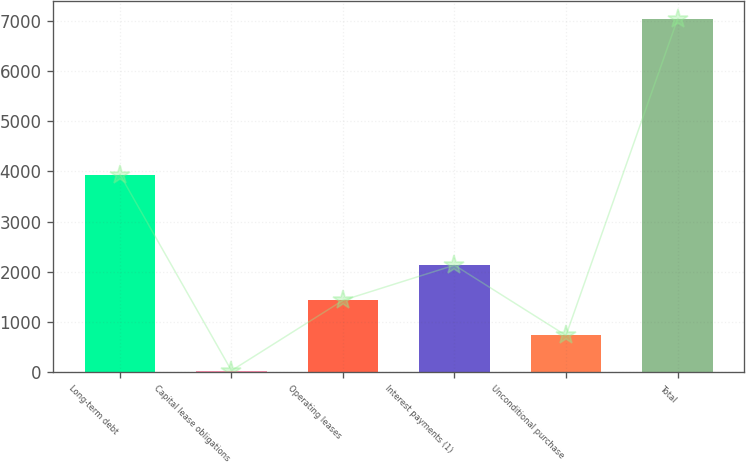<chart> <loc_0><loc_0><loc_500><loc_500><bar_chart><fcel>Long-term debt<fcel>Capital lease obligations<fcel>Operating leases<fcel>Interest payments (1)<fcel>Unconditional purchase<fcel>Total<nl><fcel>3939<fcel>32<fcel>1432.4<fcel>2132.6<fcel>732.2<fcel>7034<nl></chart> 